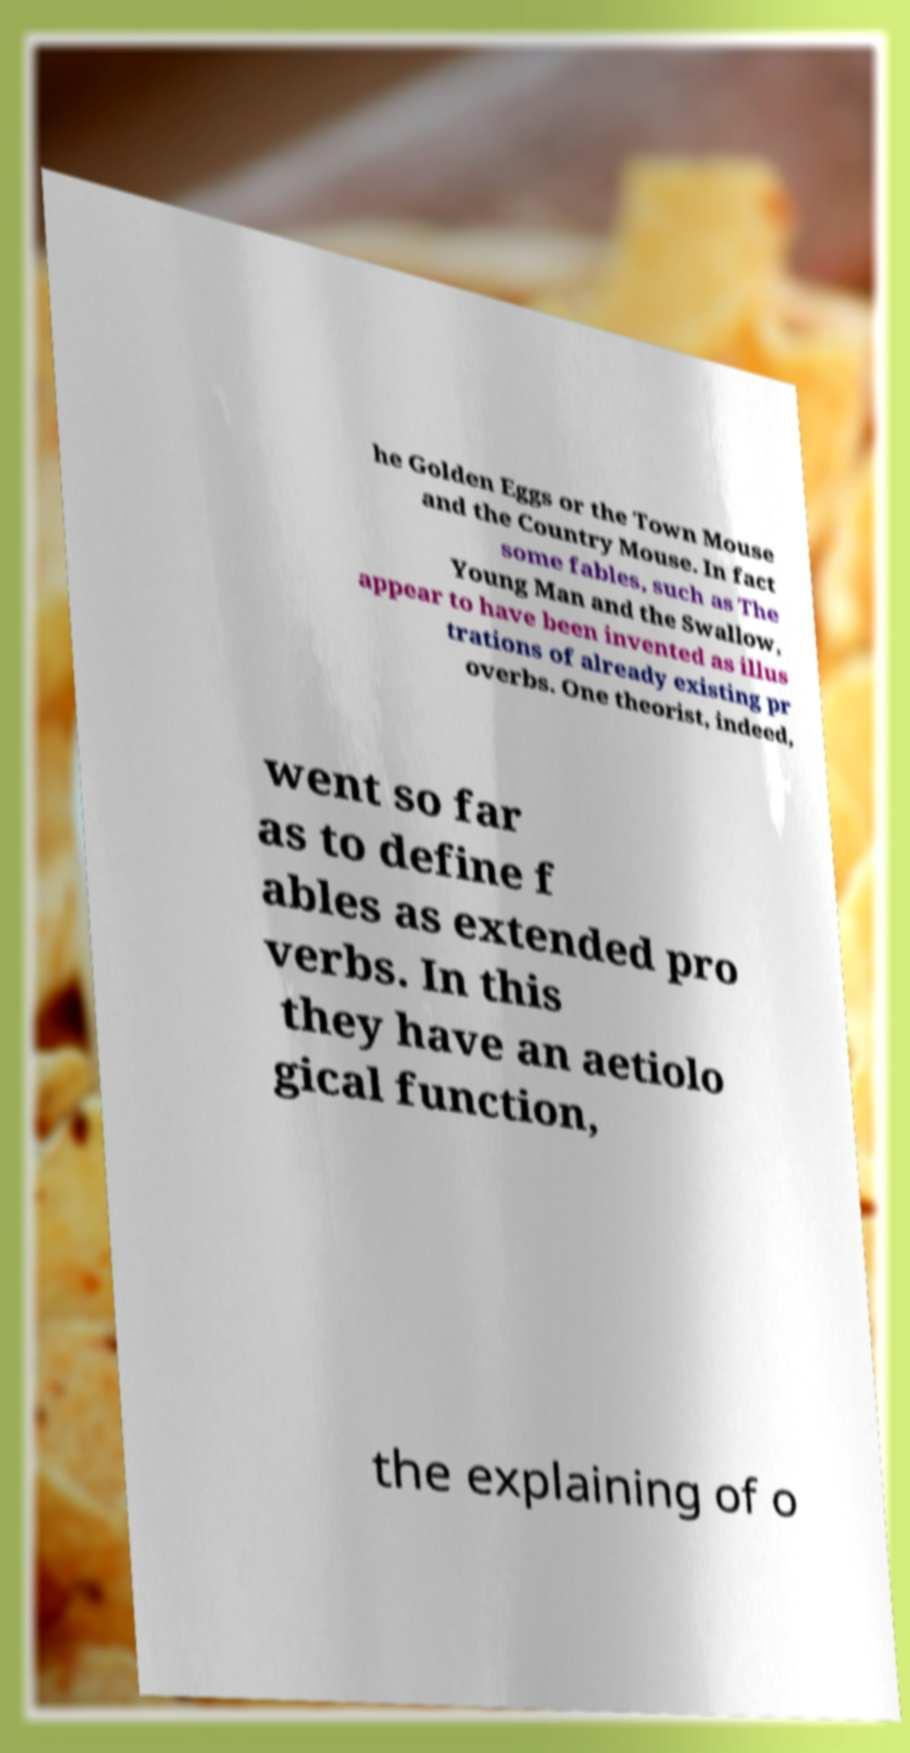What messages or text are displayed in this image? I need them in a readable, typed format. he Golden Eggs or the Town Mouse and the Country Mouse. In fact some fables, such as The Young Man and the Swallow, appear to have been invented as illus trations of already existing pr overbs. One theorist, indeed, went so far as to define f ables as extended pro verbs. In this they have an aetiolo gical function, the explaining of o 